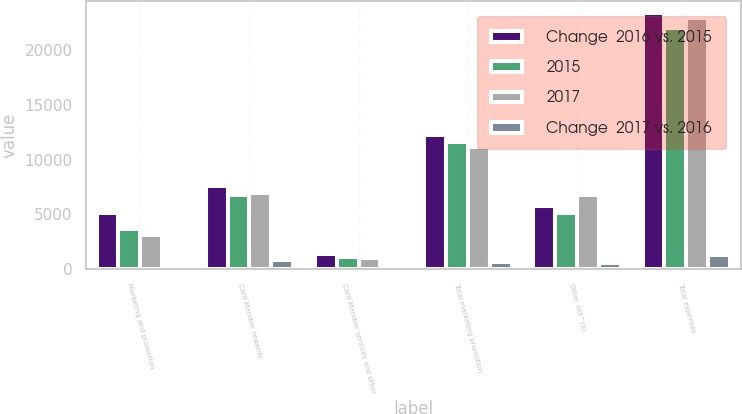Convert chart to OTSL. <chart><loc_0><loc_0><loc_500><loc_500><stacked_bar_chart><ecel><fcel>Marketing and promotion<fcel>Card Member rewards<fcel>Card Member services and other<fcel>Total marketing promotion<fcel>Other net^(a)<fcel>Total expenses<nl><fcel>Change  2016 vs. 2015<fcel>5162<fcel>7608<fcel>1439<fcel>12264<fcel>5776<fcel>23298<nl><fcel>2015<fcel>3650<fcel>6793<fcel>1133<fcel>11576<fcel>5162<fcel>21997<nl><fcel>2017<fcel>3109<fcel>6996<fcel>1018<fcel>11123<fcel>6793<fcel>22892<nl><fcel>Change  2017 vs. 2016<fcel>433<fcel>815<fcel>306<fcel>688<fcel>614<fcel>1301<nl></chart> 